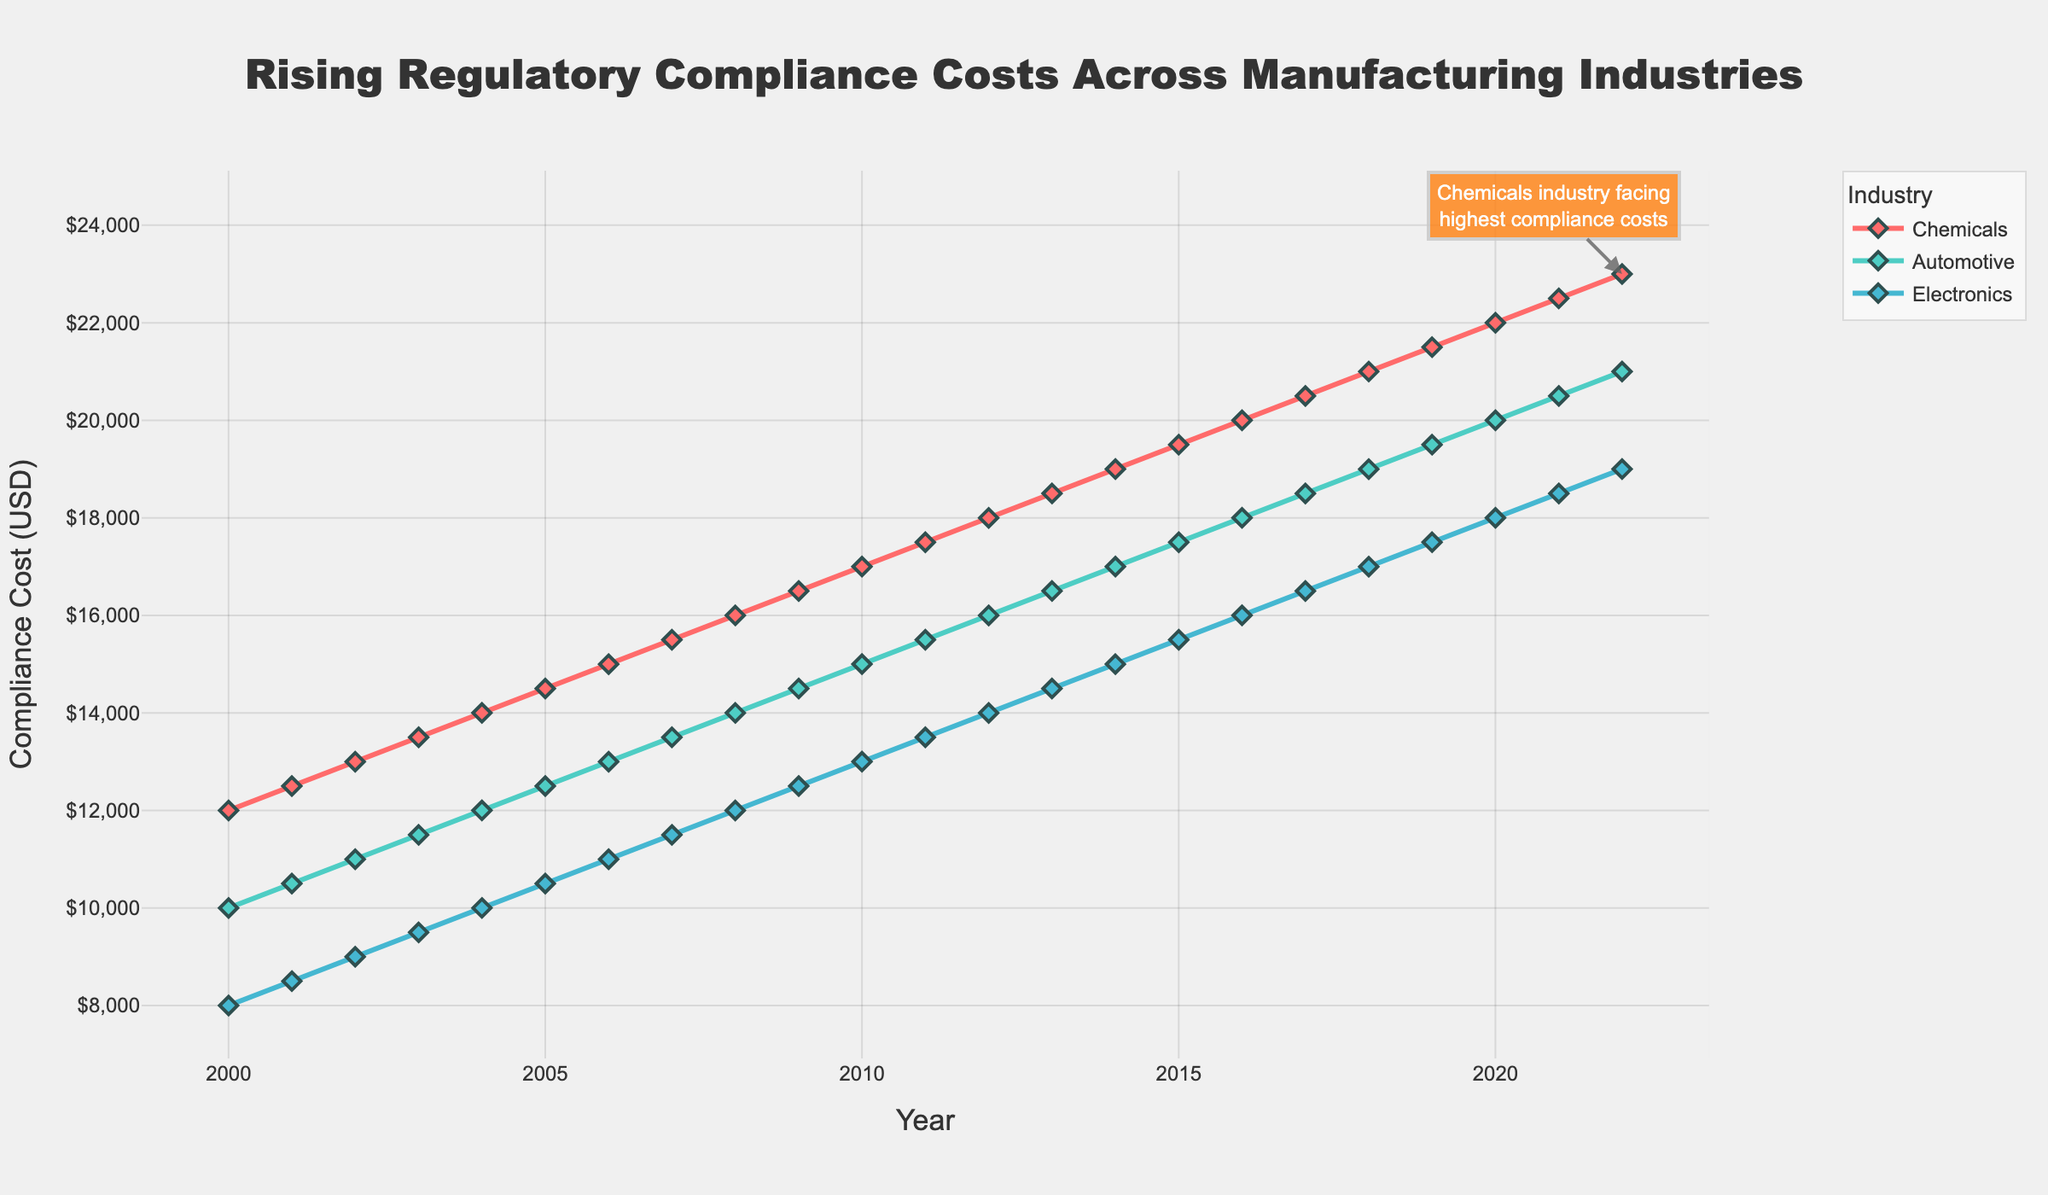What is the title of the plot? The title is usually located at the top of the plot. It provides a summary of what the plot represents.
Answer: Rising Regulatory Compliance Costs Across Manufacturing Industries Which industry has the highest compliance costs in 2022? We look at the end of the plot (year 2022) and observe the colored lines representing different industries to find the highest y-value.
Answer: Chemicals What trend do you observe in the compliance costs for the Automotive industry from 2000 to 2022? Observe the line corresponding to the Automotive industry (denoted by a specific color) and note its trajectory over time.
Answer: Increasing How much did the compliance costs for the Electronics industry increase from 2000 to 2022? Find the y-values for the Electronics industry in the years 2000 and 2022. Subtract the 2000 value from the 2022 value to get the difference: 19000 - 8000.
Answer: $11,000 Compare the compliance costs between the Chemicals and Electronics industries in 2005. Which is higher and by how much? Locate the y-values for both industries in 2005. Subtract the lower value from the higher one: Chemicals (14500) - Electronics (10500).
Answer: Chemicals by $4,000 Is there any year where the compliance costs for Chemicals and Automotive industries were the same? Compare the y-values of Chemicals and Automotive year-by-year to see if there is any overlap.
Answer: No What is the average annual increase in compliance costs for the Automotive industry over the period 2000-2022? Find the total increase in compliance costs over the 22-year period and divide by the number of years: (21000 - 10000) / 22.
Answer: $500 per year By what percentage did the compliance costs for the Chemicals industry increase from 2000 to 2022? Calculate the percentage increase using the formula (Final - Initial) / Initial * 100: (23000 - 12000) / 12000 * 100.
Answer: 91.67% Which industry shows the most consistent increase in compliance costs over the years? Observe the smoothness and slope of the lines for all industries. Compare which line shows the least amount of variation and a steady upward trend.
Answer: Automotive Between which consecutive years did the Chemicals industry see the highest annual increase in compliance costs? Determine the annual increments by subtracting consecutive years' y-values for Chemicals. Identify the highest increment.
Answer: 2001 to 2002 